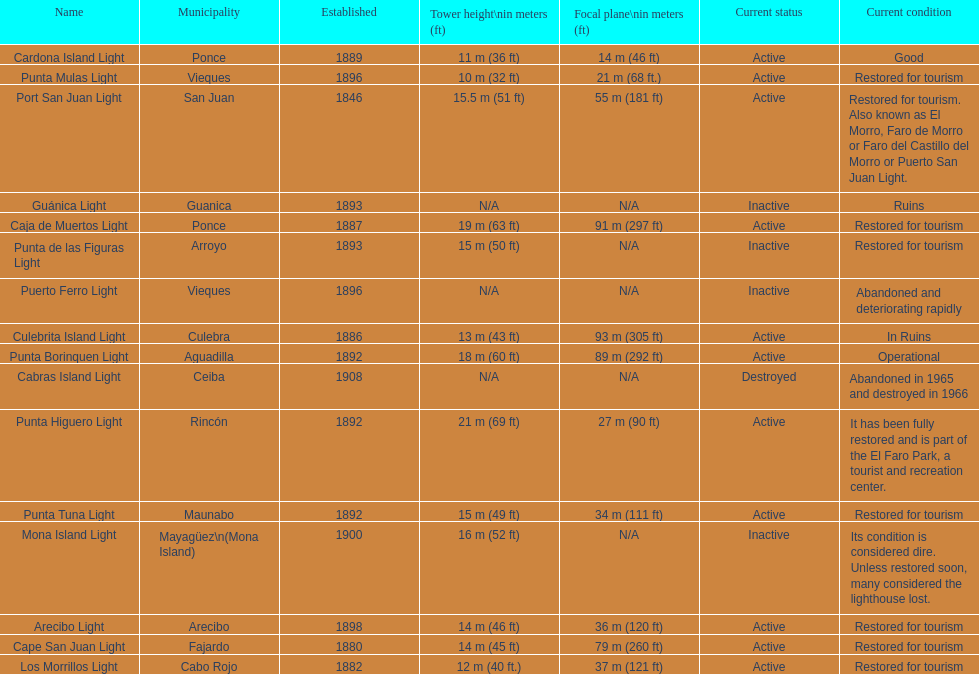How many towers are at least 18 meters tall? 3. 